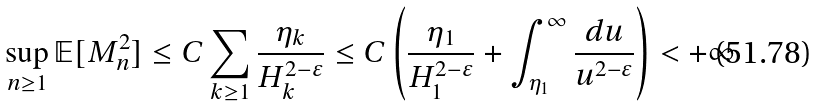Convert formula to latex. <formula><loc_0><loc_0><loc_500><loc_500>\sup _ { n \geq 1 } \mathbb { E } [ M _ { n } ^ { 2 } ] \leq C \sum _ { k \geq 1 } \frac { \eta _ { k } } { H _ { k } ^ { 2 - \varepsilon } } \leq C \left ( \frac { \eta _ { 1 } } { H _ { 1 } ^ { 2 - \varepsilon } } + \int _ { \eta _ { 1 } } ^ { \infty } \frac { d u } { u ^ { 2 - \varepsilon } } \right ) < + \infty</formula> 